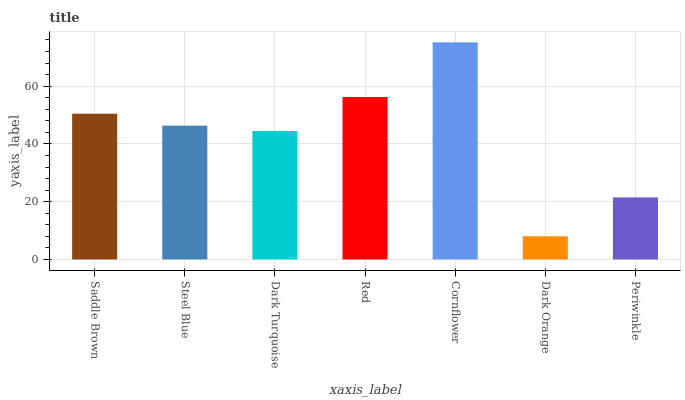Is Steel Blue the minimum?
Answer yes or no. No. Is Steel Blue the maximum?
Answer yes or no. No. Is Saddle Brown greater than Steel Blue?
Answer yes or no. Yes. Is Steel Blue less than Saddle Brown?
Answer yes or no. Yes. Is Steel Blue greater than Saddle Brown?
Answer yes or no. No. Is Saddle Brown less than Steel Blue?
Answer yes or no. No. Is Steel Blue the high median?
Answer yes or no. Yes. Is Steel Blue the low median?
Answer yes or no. Yes. Is Periwinkle the high median?
Answer yes or no. No. Is Periwinkle the low median?
Answer yes or no. No. 